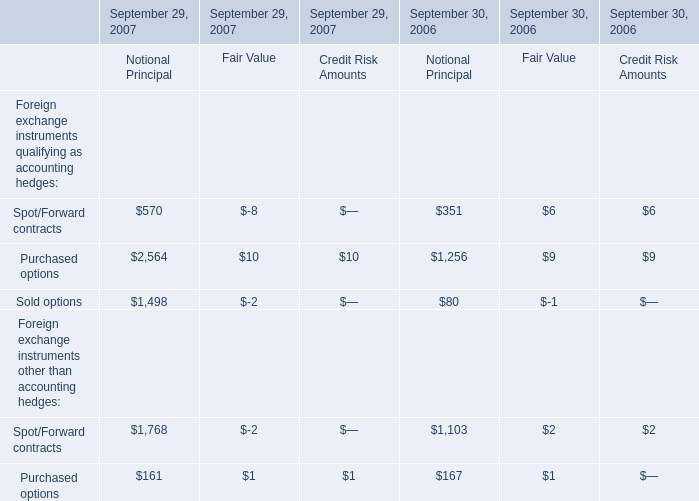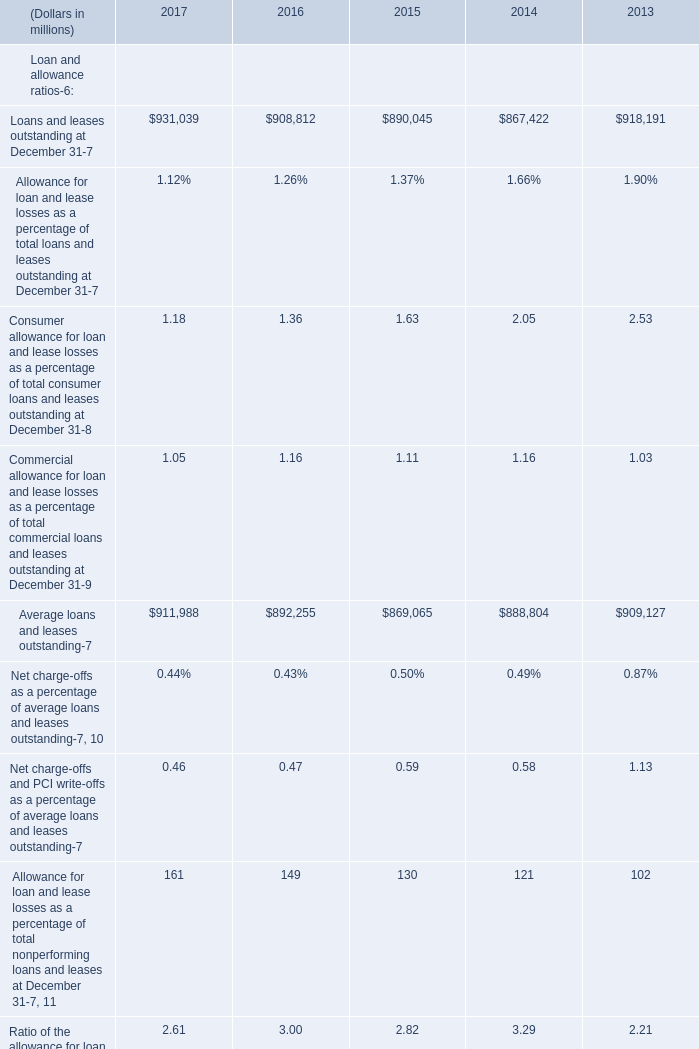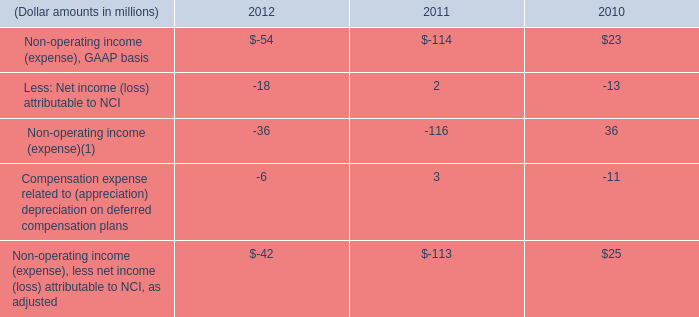What's the average of Purchased options of September 29, 2007 Notional Principal, and Average loans and leases outstanding of 2013 ? 
Computations: ((2564.0 + 909127.0) / 2)
Answer: 455845.5. 